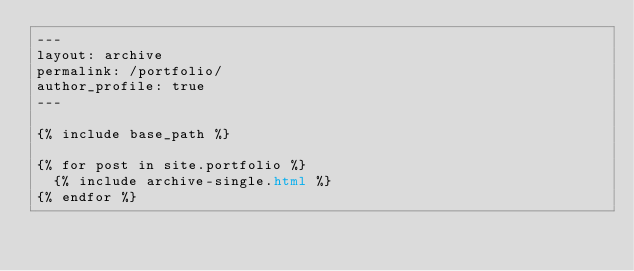<code> <loc_0><loc_0><loc_500><loc_500><_HTML_>---
layout: archive
permalink: /portfolio/
author_profile: true
---

{% include base_path %}

{% for post in site.portfolio %}
  {% include archive-single.html %}
{% endfor %}

</code> 